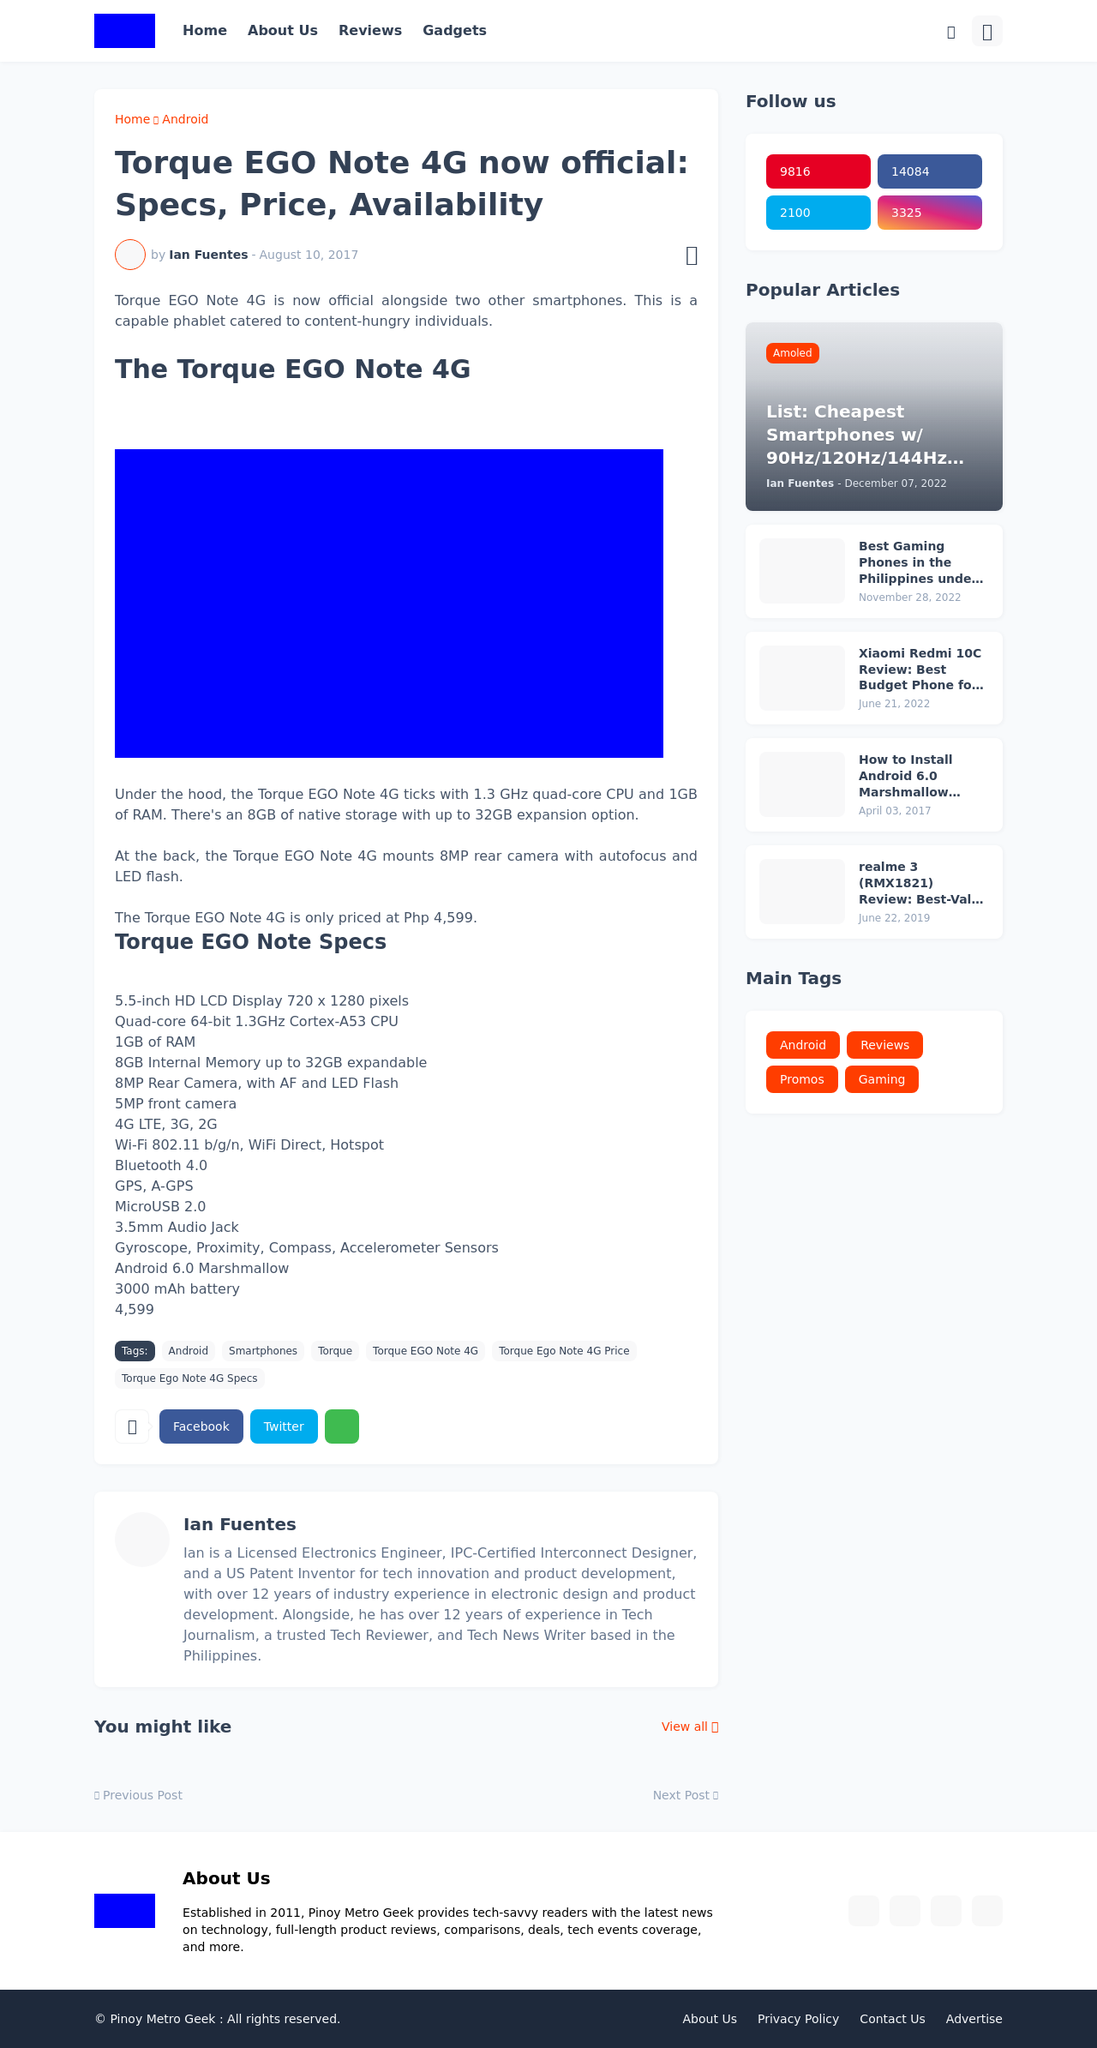Can you suggest any features that can be added to this type of tech news website to enhance user engagement? To enhance user engagement on a tech news website like this, features such as a comment section where readers can discuss articles, a newsletter signup to keep visitors updated, interactive polls related to technology topics, and a 'related articles' section to increase time on site can be very effective. Incorporating social sharing buttons and maybe a forum for tech enthusiasts can also increase engagement.  What are some unique content ideas that could set this tech website apart from its competitors? Unique content ideas for this tech website could include in-depth technical teardowns of devices, interviews with industry leaders, exclusive news on technology advancements, step-by-step guides on using new technologies, and user-generated content competitions. Additionally, hosting webinars or podcasts with tech experts discussing current trends and future predictions would offer great value to its audience. 